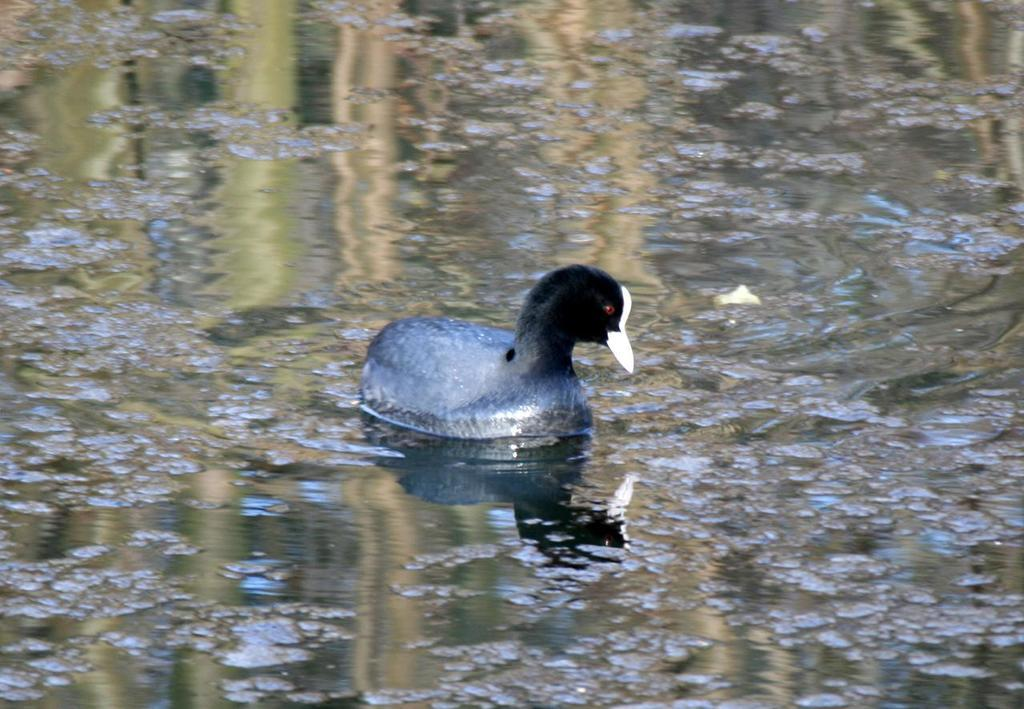What animal is present in the image? There is a duck in the image. Where is the duck located? The duck is in the water. What type of adjustment does the duck need to make in order to access its credit card in the image? There is no credit card or adjustment mentioned in the image; it only features a duck in the water. 